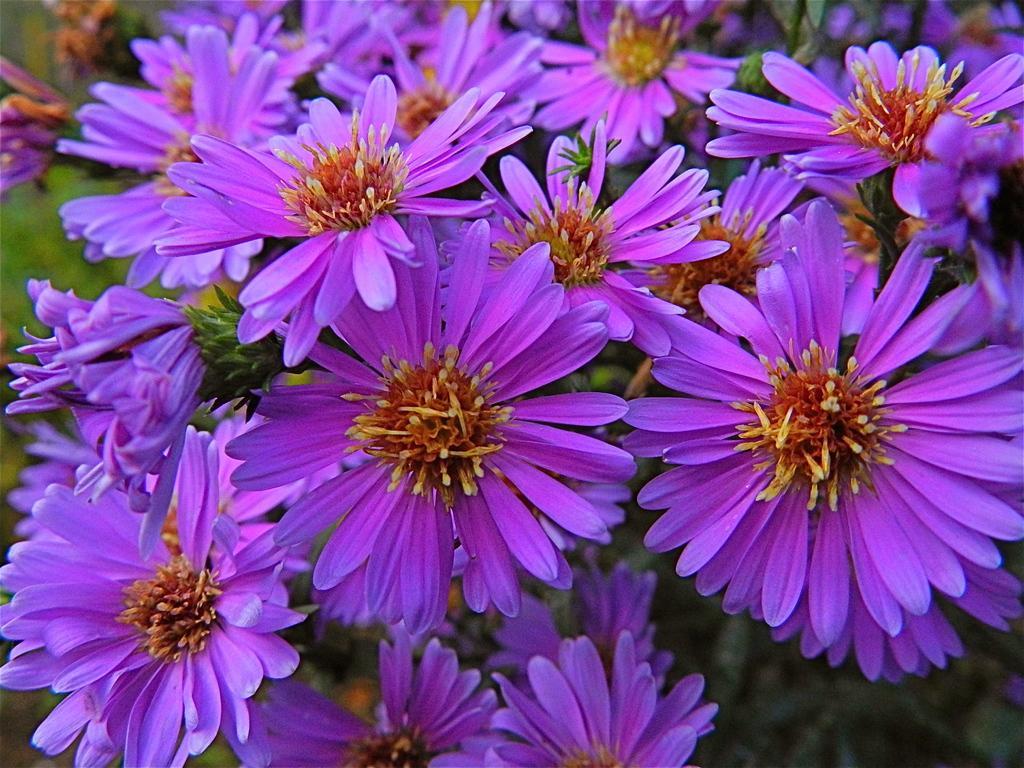Please provide a concise description of this image. In this picture we can see flowers and in the background we can see plants and it is blurry. 